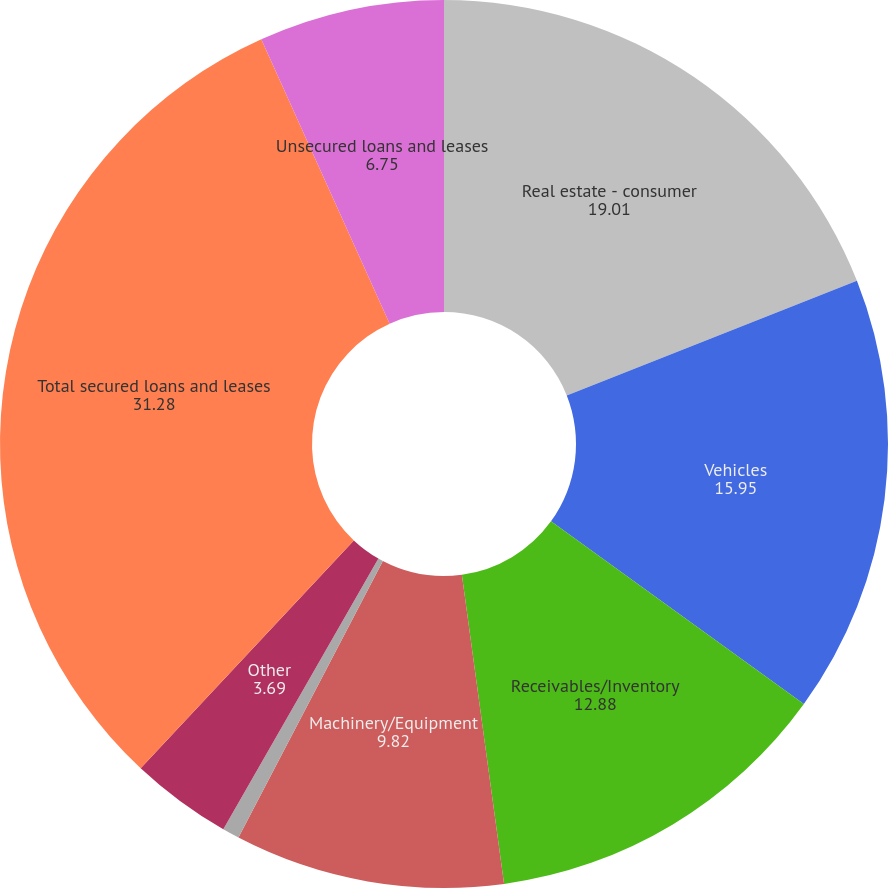Convert chart to OTSL. <chart><loc_0><loc_0><loc_500><loc_500><pie_chart><fcel>Real estate - consumer<fcel>Vehicles<fcel>Receivables/Inventory<fcel>Machinery/Equipment<fcel>Securities/Deposits<fcel>Other<fcel>Total secured loans and leases<fcel>Unsecured loans and leases<nl><fcel>19.01%<fcel>15.95%<fcel>12.88%<fcel>9.82%<fcel>0.62%<fcel>3.69%<fcel>31.28%<fcel>6.75%<nl></chart> 